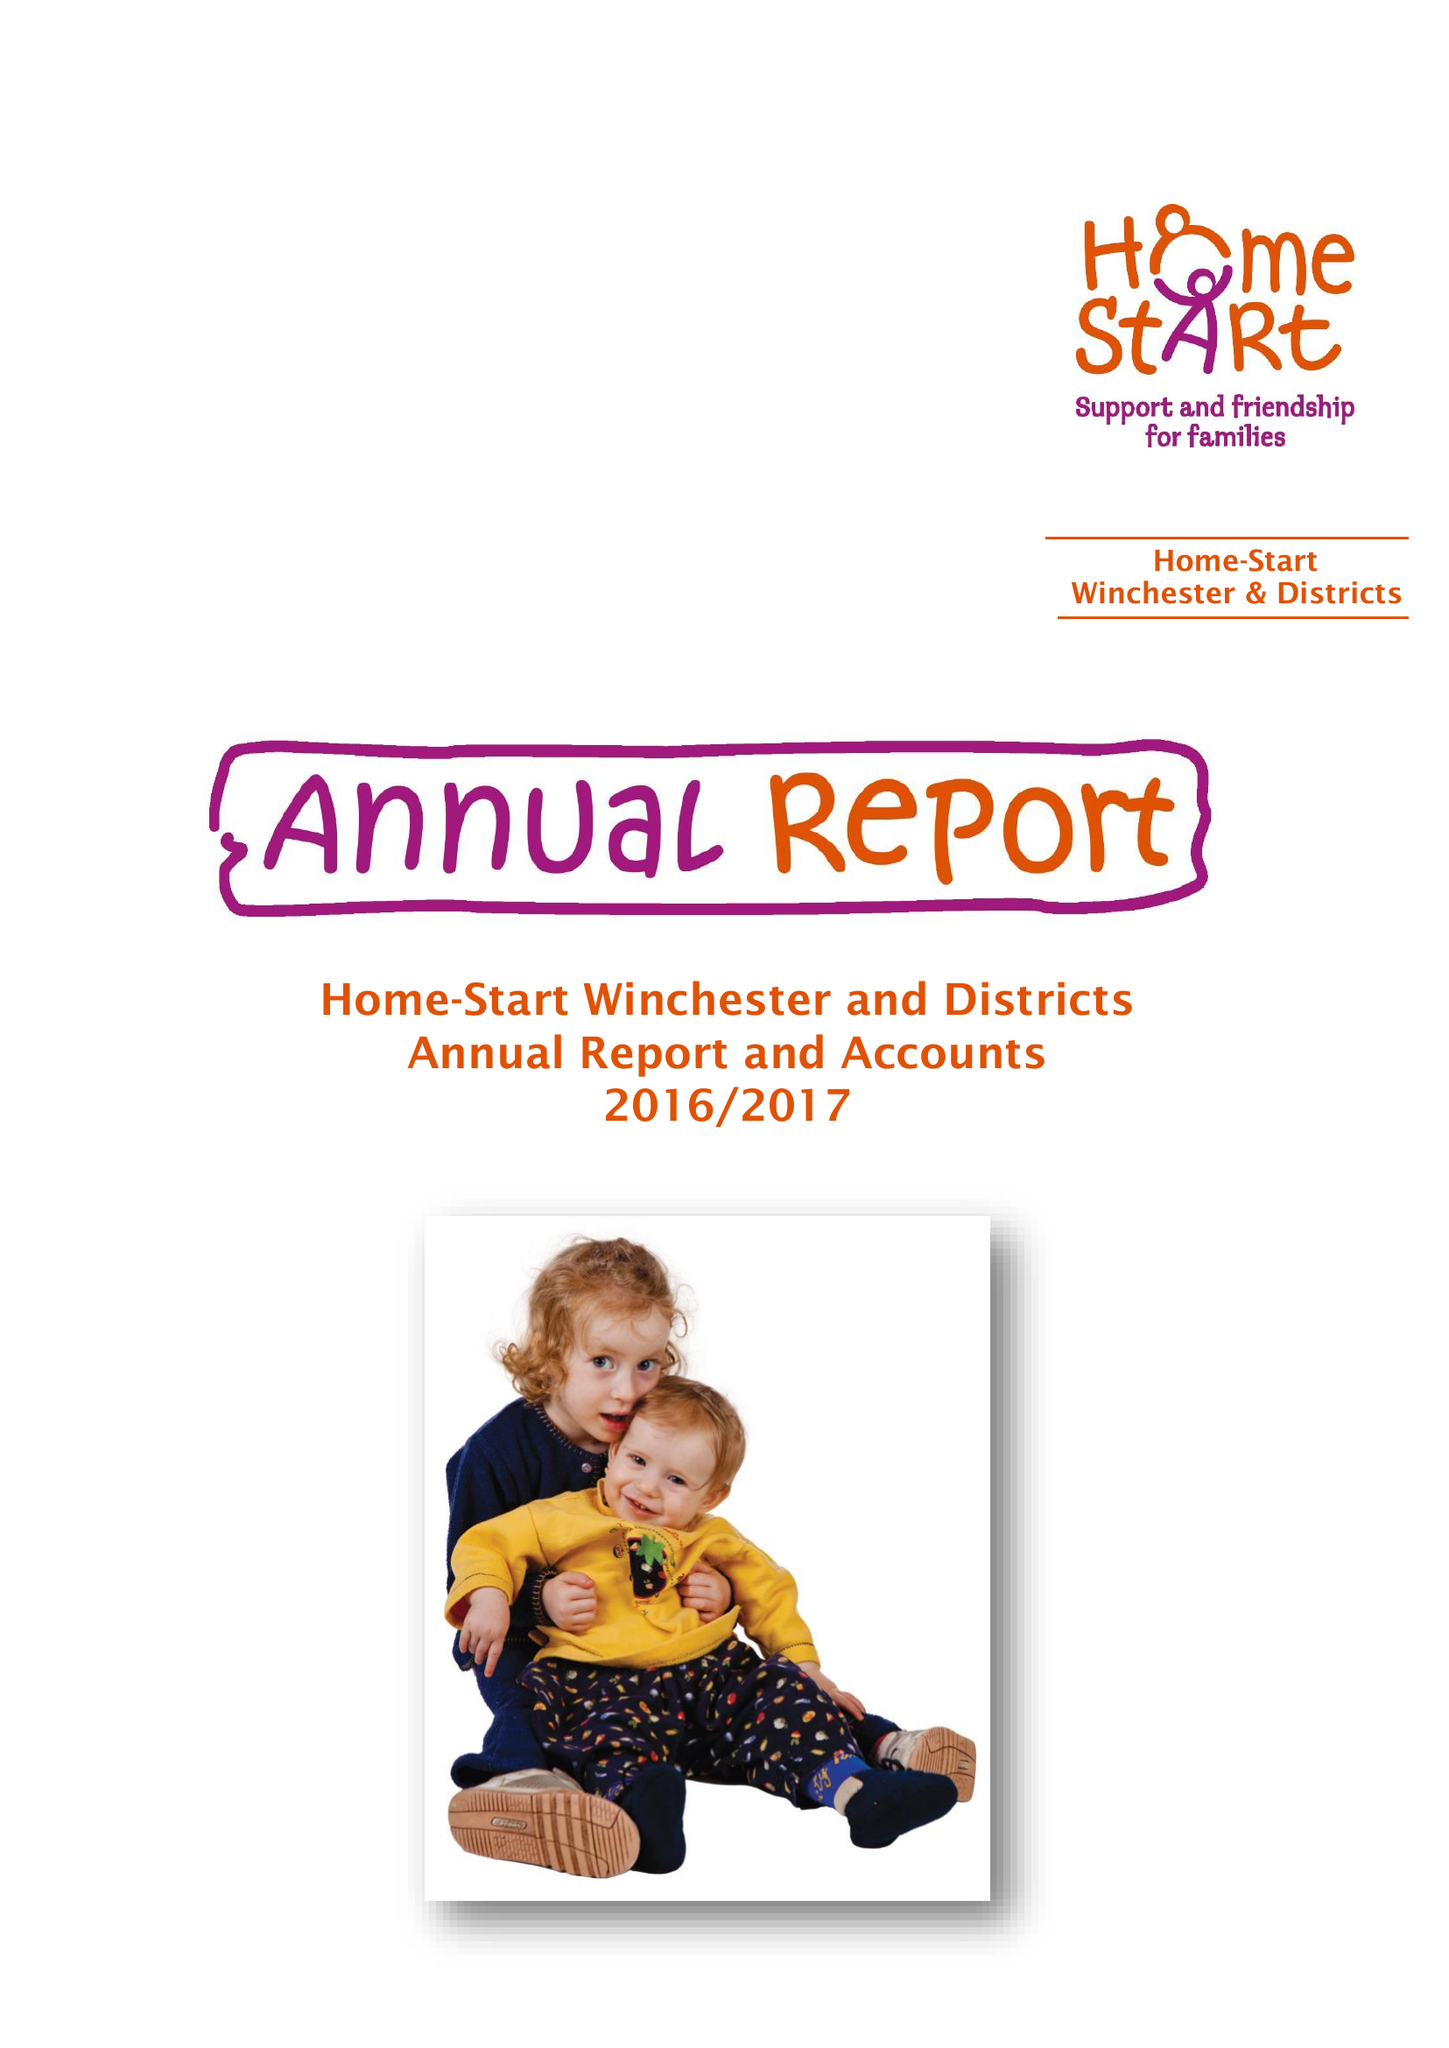What is the value for the spending_annually_in_british_pounds?
Answer the question using a single word or phrase. 75712.00 